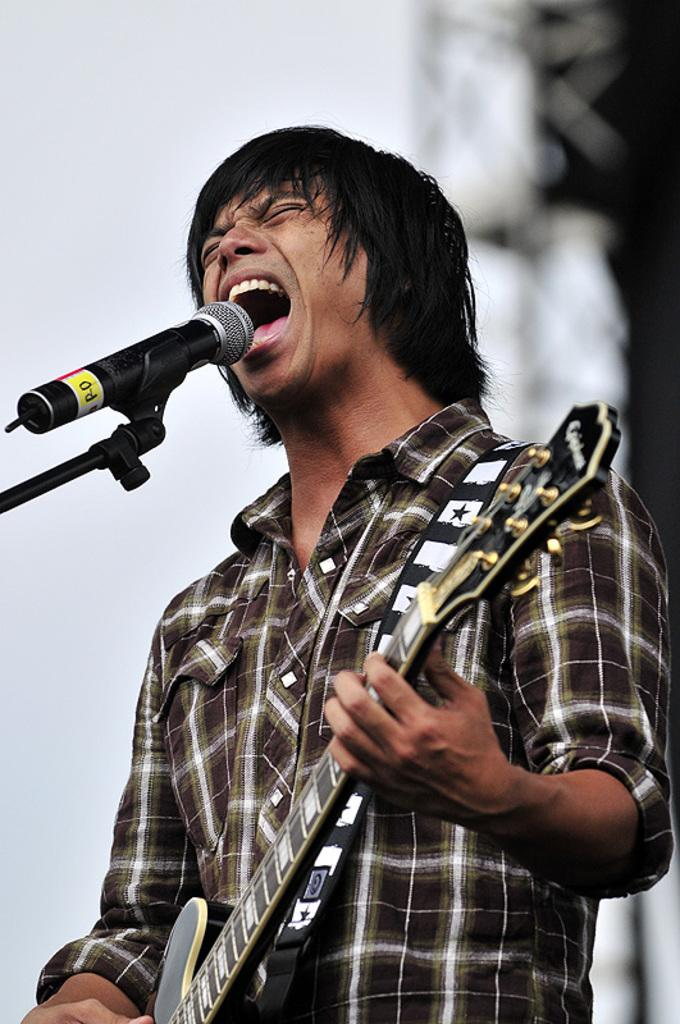Who is the main subject in the image? There is a man in the image. What is the man holding in the image? The man is holding a guitar. What is the man doing with the guitar? The man is playing the guitar. What else is the man doing in the image? The man is singing on a microphone. What time is displayed on the calculator in the image? There is no calculator present in the image. How does the bomb affect the man's performance in the image? There is no bomb present in the image, so it does not affect the man's performance. 